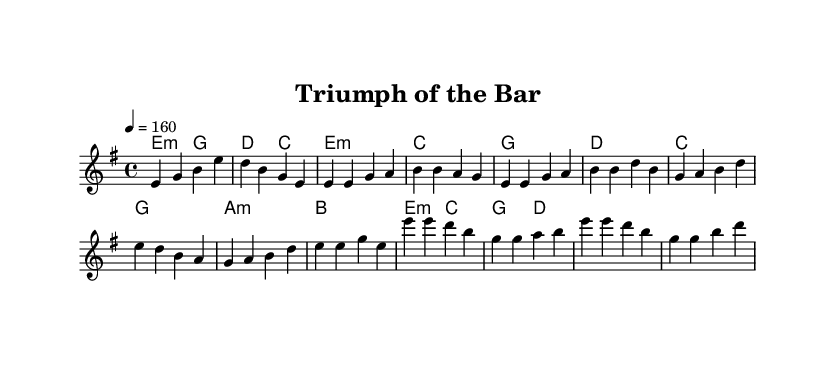What is the key signature of this music? The key signature is E minor, which has one sharp (F#). This can be determined by looking at the key signature indicated at the beginning of the score, which shows one sharp, signifying E minor and its relative major, G major.
Answer: E minor What is the time signature of this music? The time signature is 4/4, which is indicated at the beginning of the score. This means there are four beats per measure, and the quarter note gets one beat.
Answer: 4/4 What is the tempo marking of this music? The tempo marking is quarter note equals 160 beats per minute, which dictates how fast the music should be played. This is noted in the tempo indication at the start of the piece.
Answer: 160 What is the main theme of the lyrics? The main theme of the lyrics revolves around overcoming challenges and achieving victory, specifically in the context of facing the bar exam and persevering despite difficulties. This can be understood by analyzing the lyrics' content, which emphasizes determination and eventual success.
Answer: Overcoming challenges How many sections are there in this song? There are four distinct sections in the song: Intro, Verse, Pre-chorus, and Chorus. This is based on the structural labels present in the score, which clearly define the different parts of the composition.
Answer: Four Identify the chords used in the chorus. The chords used in the chorus are E minor, C major, G major, and D major. This can be determined by examining the chord section accompanying the melody during the chorus, which outlines these specific chords.
Answer: E minor, C major, G major, D major 